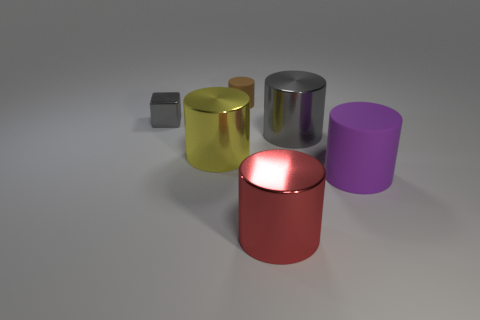What color is the tiny matte cylinder?
Keep it short and to the point. Brown. Is there a cube of the same color as the tiny metal thing?
Offer a terse response. No. There is a large metal cylinder that is on the left side of the small matte object; is its color the same as the tiny cylinder?
Give a very brief answer. No. What number of things are shiny things that are to the right of the brown cylinder or shiny things?
Give a very brief answer. 4. There is a small brown object; are there any big rubber things behind it?
Your answer should be compact. No. There is another thing that is the same color as the tiny metal object; what is its material?
Your answer should be compact. Metal. Do the tiny thing that is on the left side of the big yellow thing and the small brown object have the same material?
Provide a succinct answer. No. There is a big metallic thing in front of the large purple rubber thing in front of the small cylinder; is there a red cylinder left of it?
Your answer should be compact. No. How many cylinders are small brown objects or small red rubber things?
Your response must be concise. 1. There is a big thing in front of the purple matte cylinder; what material is it?
Keep it short and to the point. Metal. 